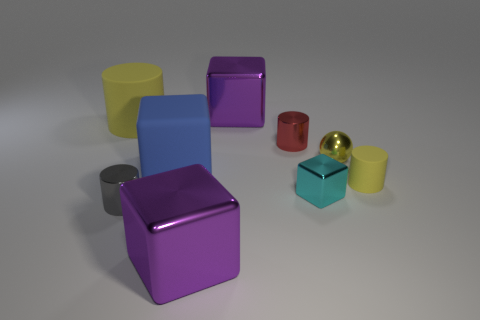There is a cyan object that is the same shape as the large blue matte object; what size is it?
Ensure brevity in your answer.  Small. How many large cylinders are on the left side of the tiny cyan metallic block?
Give a very brief answer. 1. There is a small metal cylinder right of the big purple object that is behind the gray shiny object; what color is it?
Your answer should be very brief. Red. Is there anything else that has the same shape as the small yellow metal object?
Give a very brief answer. No. Are there an equal number of large things to the right of the big blue block and rubber objects on the left side of the small matte object?
Your response must be concise. Yes. What number of cylinders are either small red metallic objects or cyan things?
Ensure brevity in your answer.  1. How many other objects are there of the same material as the large blue object?
Provide a succinct answer. 2. There is a matte thing that is to the right of the blue rubber block; what is its shape?
Provide a short and direct response. Cylinder. There is a yellow cylinder on the right side of the big purple object behind the large yellow matte cylinder; what is its material?
Provide a short and direct response. Rubber. Is the number of yellow matte things left of the big blue rubber object greater than the number of large cyan cubes?
Your answer should be compact. Yes. 